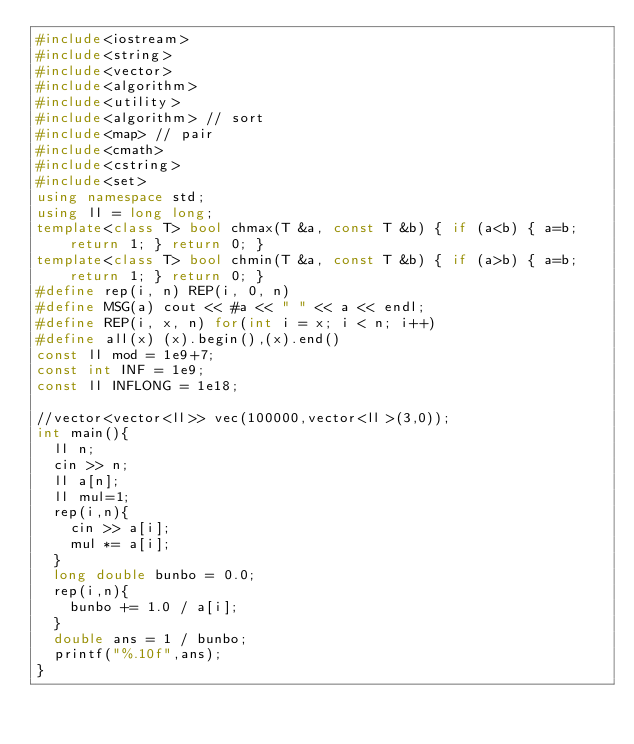<code> <loc_0><loc_0><loc_500><loc_500><_C++_>#include<iostream>
#include<string>
#include<vector>
#include<algorithm>
#include<utility>
#include<algorithm> // sort
#include<map> // pair
#include<cmath>
#include<cstring>
#include<set>
using namespace std;
using ll = long long;
template<class T> bool chmax(T &a, const T &b) { if (a<b) { a=b; return 1; } return 0; }
template<class T> bool chmin(T &a, const T &b) { if (a>b) { a=b; return 1; } return 0; }
#define rep(i, n) REP(i, 0, n)
#define MSG(a) cout << #a << " " << a << endl;
#define REP(i, x, n) for(int i = x; i < n; i++)
#define all(x) (x).begin(),(x).end()
const ll mod = 1e9+7;
const int INF = 1e9;
const ll INFLONG = 1e18;

//vector<vector<ll>> vec(100000,vector<ll>(3,0));
int main(){
  ll n;
  cin >> n;
  ll a[n];
  ll mul=1;
  rep(i,n){
    cin >> a[i];
    mul *= a[i];
  }
  long double bunbo = 0.0;
  rep(i,n){
    bunbo += 1.0 / a[i];
  }
  double ans = 1 / bunbo;
  printf("%.10f",ans);
}
</code> 